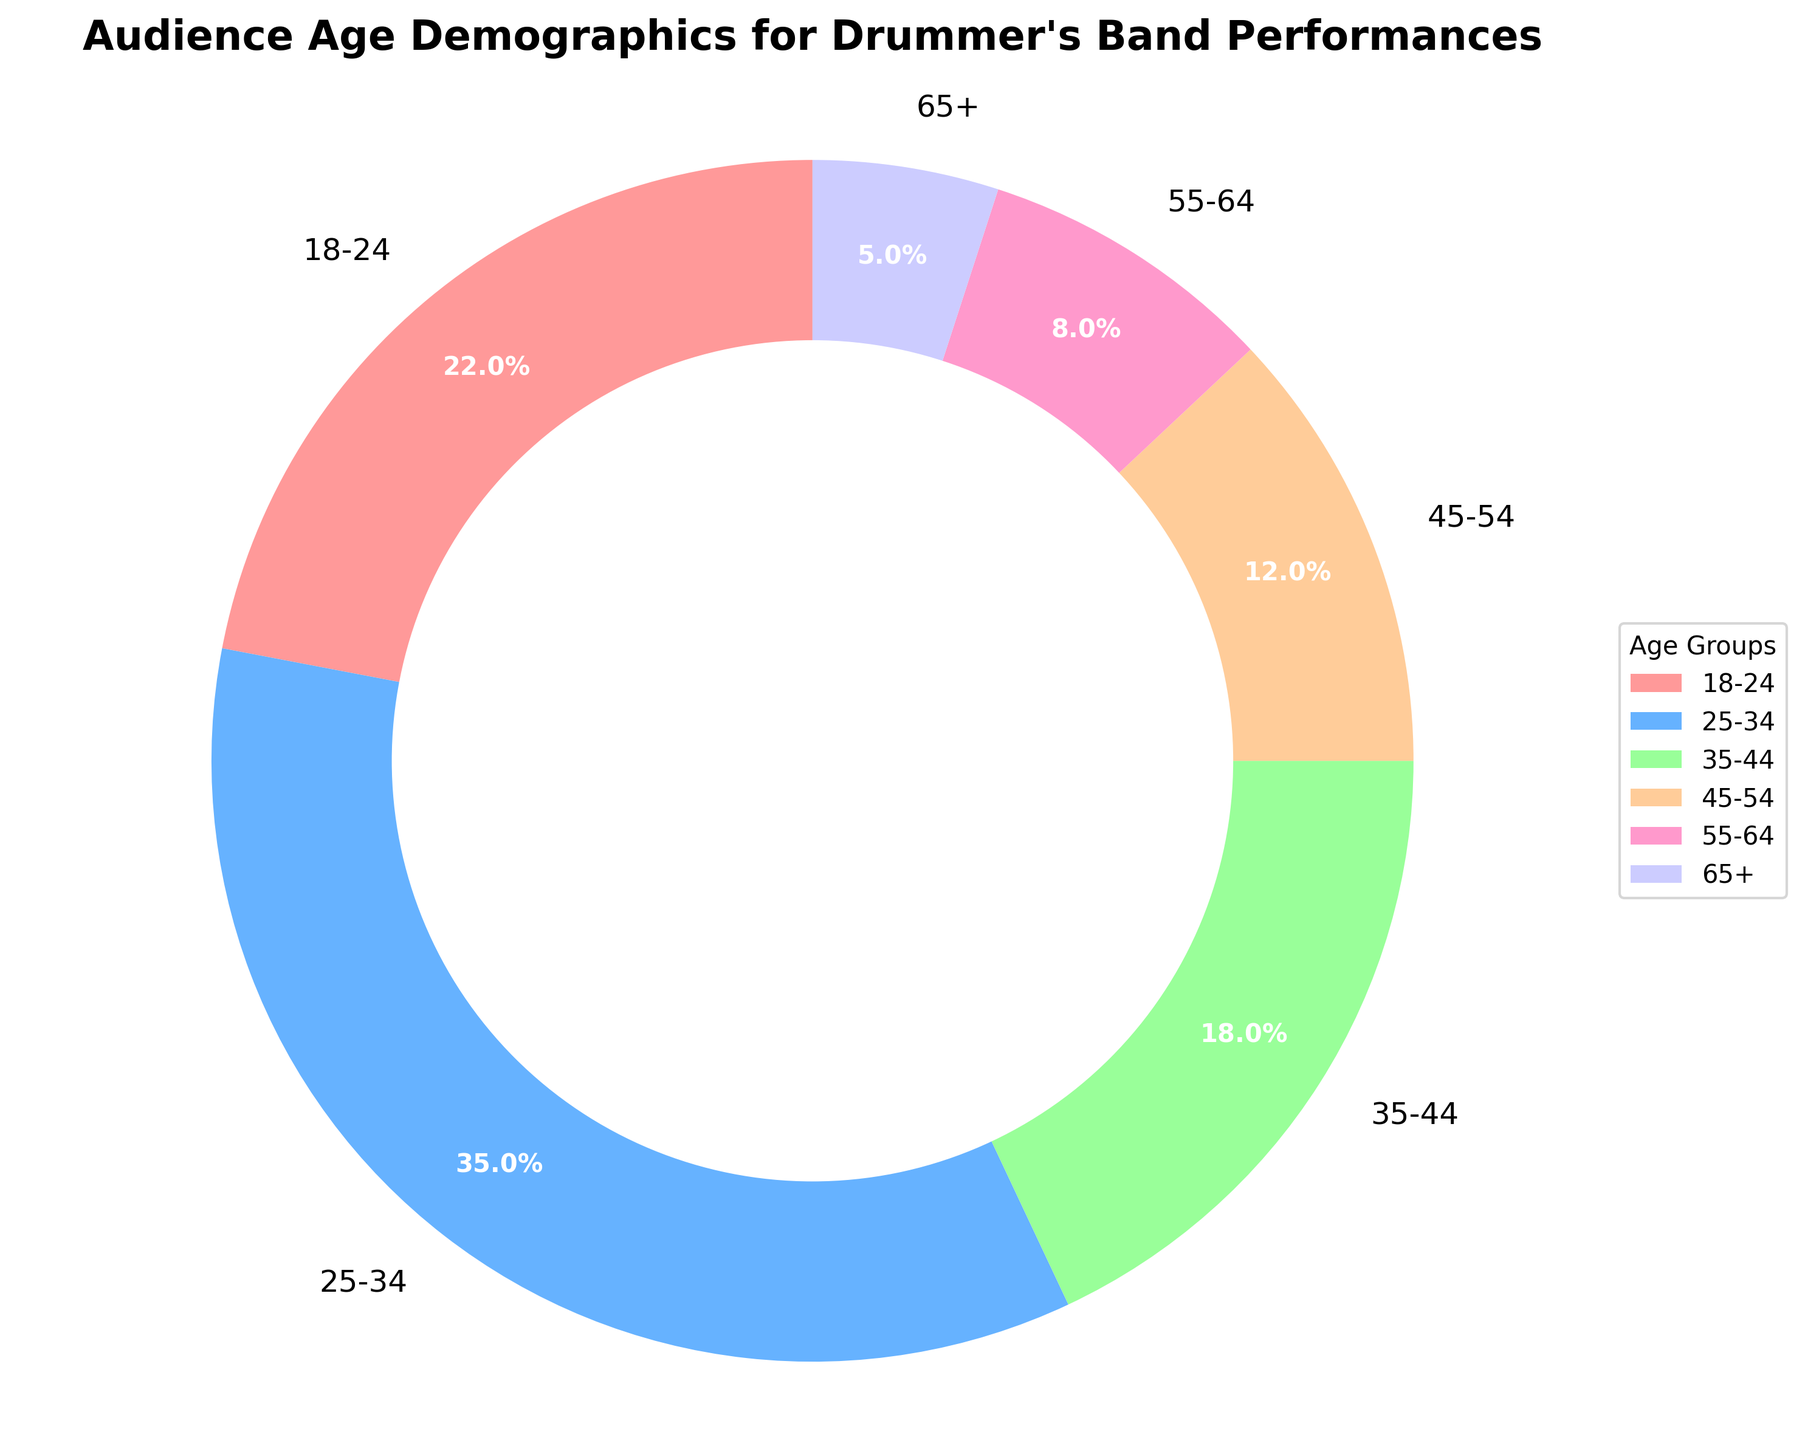What percentage of the audience is under 35 years old? To determine this, sum the percentages of the 18-24 and 25-34 age groups. These groups are 22% and 35% respectively. Adding them together provides the total percentage.
Answer: 57% Which age group has the smallest percentage of the audience? By observing the pie chart, look for the smallest segment. The segment labeled "65+" is the smallest with 5%.
Answer: 65+ Is the 35-44 age group larger or smaller than the 45-54 age group, and by how much? Identify the percentages for the 35-44 and 45-54 age groups from the chart. The 35-44 age group is 18%, and the 45-54 age group is 12%. Subtract the smaller percentage from the larger to find the difference.
Answer: Larger by 6% How does the percentage of the 55-64 age group compare to the total percentage of the 45-54 and 65+ age groups combined? Find the percentage for the 55-64 age group (8%) and the combined percentage for the 45-54 (12%) and 65+ (5%) age groups. Add the latter two percentages (12% + 5% = 17%) and compare this combined result to the 55-64 group's 8%.
Answer: Smaller by 9% What is the most common age group in the audience? Determine which segment of the pie chart is the largest. The 25-34 age group has the largest slice, representing 35%.
Answer: 25-34 Which two adjacent age groups together account for the smallest percentage of the audience? Check the age groups next to each other and sum their percentages. The 55-64 (8%) and 65+ (5%) age groups together total 13%, which is the smallest combined percentage of adjacent groups.
Answer: 55-64 and 65+ If the band wants to target promotions to the groups that together make up at least 50% of the audience, which age groups should they focus on? Identify age groups whose summed percentages meet or exceed 50%. The 18-24 (22%) and 25-34 (35%) groups together total 57%, which meets this criteria.
Answer: 18-24 and 25-34 What is the combined audience percentage for those aged 45 and above? Sum the percentages of the 45-54, 55-64, and 65+ age groups. These groups represent 12%, 8%, and 5% respectively. Adding them together provides the combined percentage.
Answer: 25% Which age group has almost double the audience percentage of the 55-64 age group? Find the percentage for the 55-64 age group (8%) and determine which other group's percentage is almost double. The 18-24 age group at 22% is close to double 8% (16%).
Answer: 18-24 